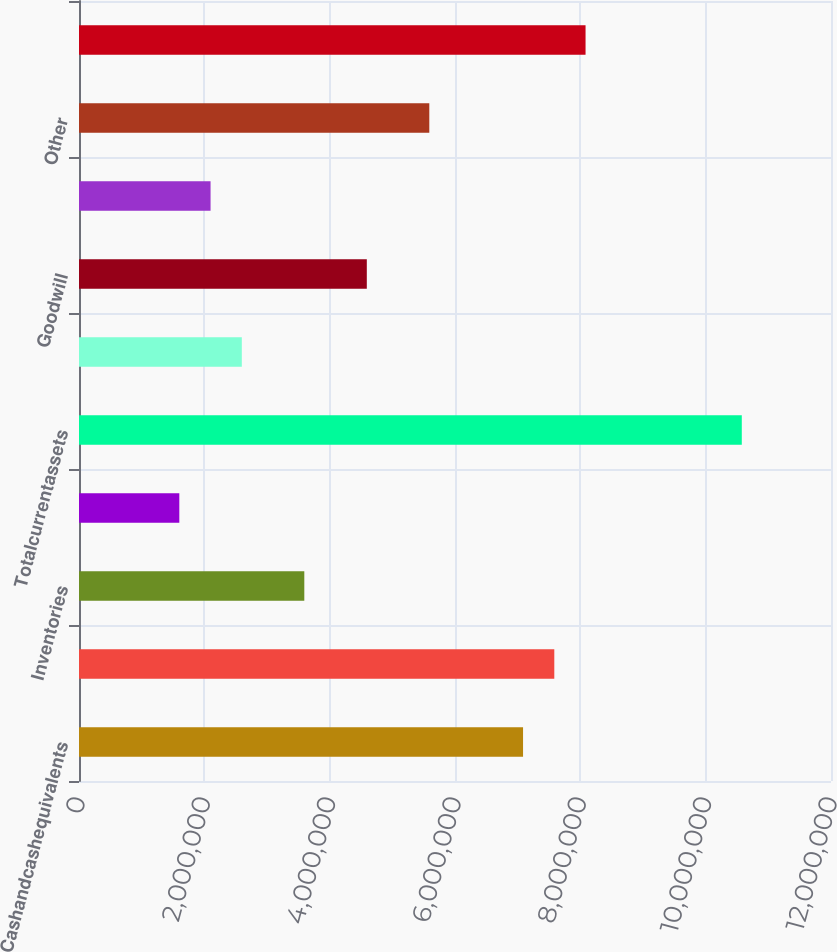Convert chart. <chart><loc_0><loc_0><loc_500><loc_500><bar_chart><fcel>Cashandcashequivalents<fcel>Accounts receivable less<fcel>Inventories<fcel>Unnamed: 3<fcel>Totalcurrentassets<fcel>Propertyplantandequipmentnet<fcel>Goodwill<fcel>Otherintangiblesnet<fcel>Other<fcel>Totalotherassets<nl><fcel>7.08597e+06<fcel>7.58463e+06<fcel>3.59541e+06<fcel>1.6008e+06<fcel>1.05765e+07<fcel>2.59811e+06<fcel>4.59271e+06<fcel>2.09945e+06<fcel>5.59002e+06<fcel>8.08328e+06<nl></chart> 